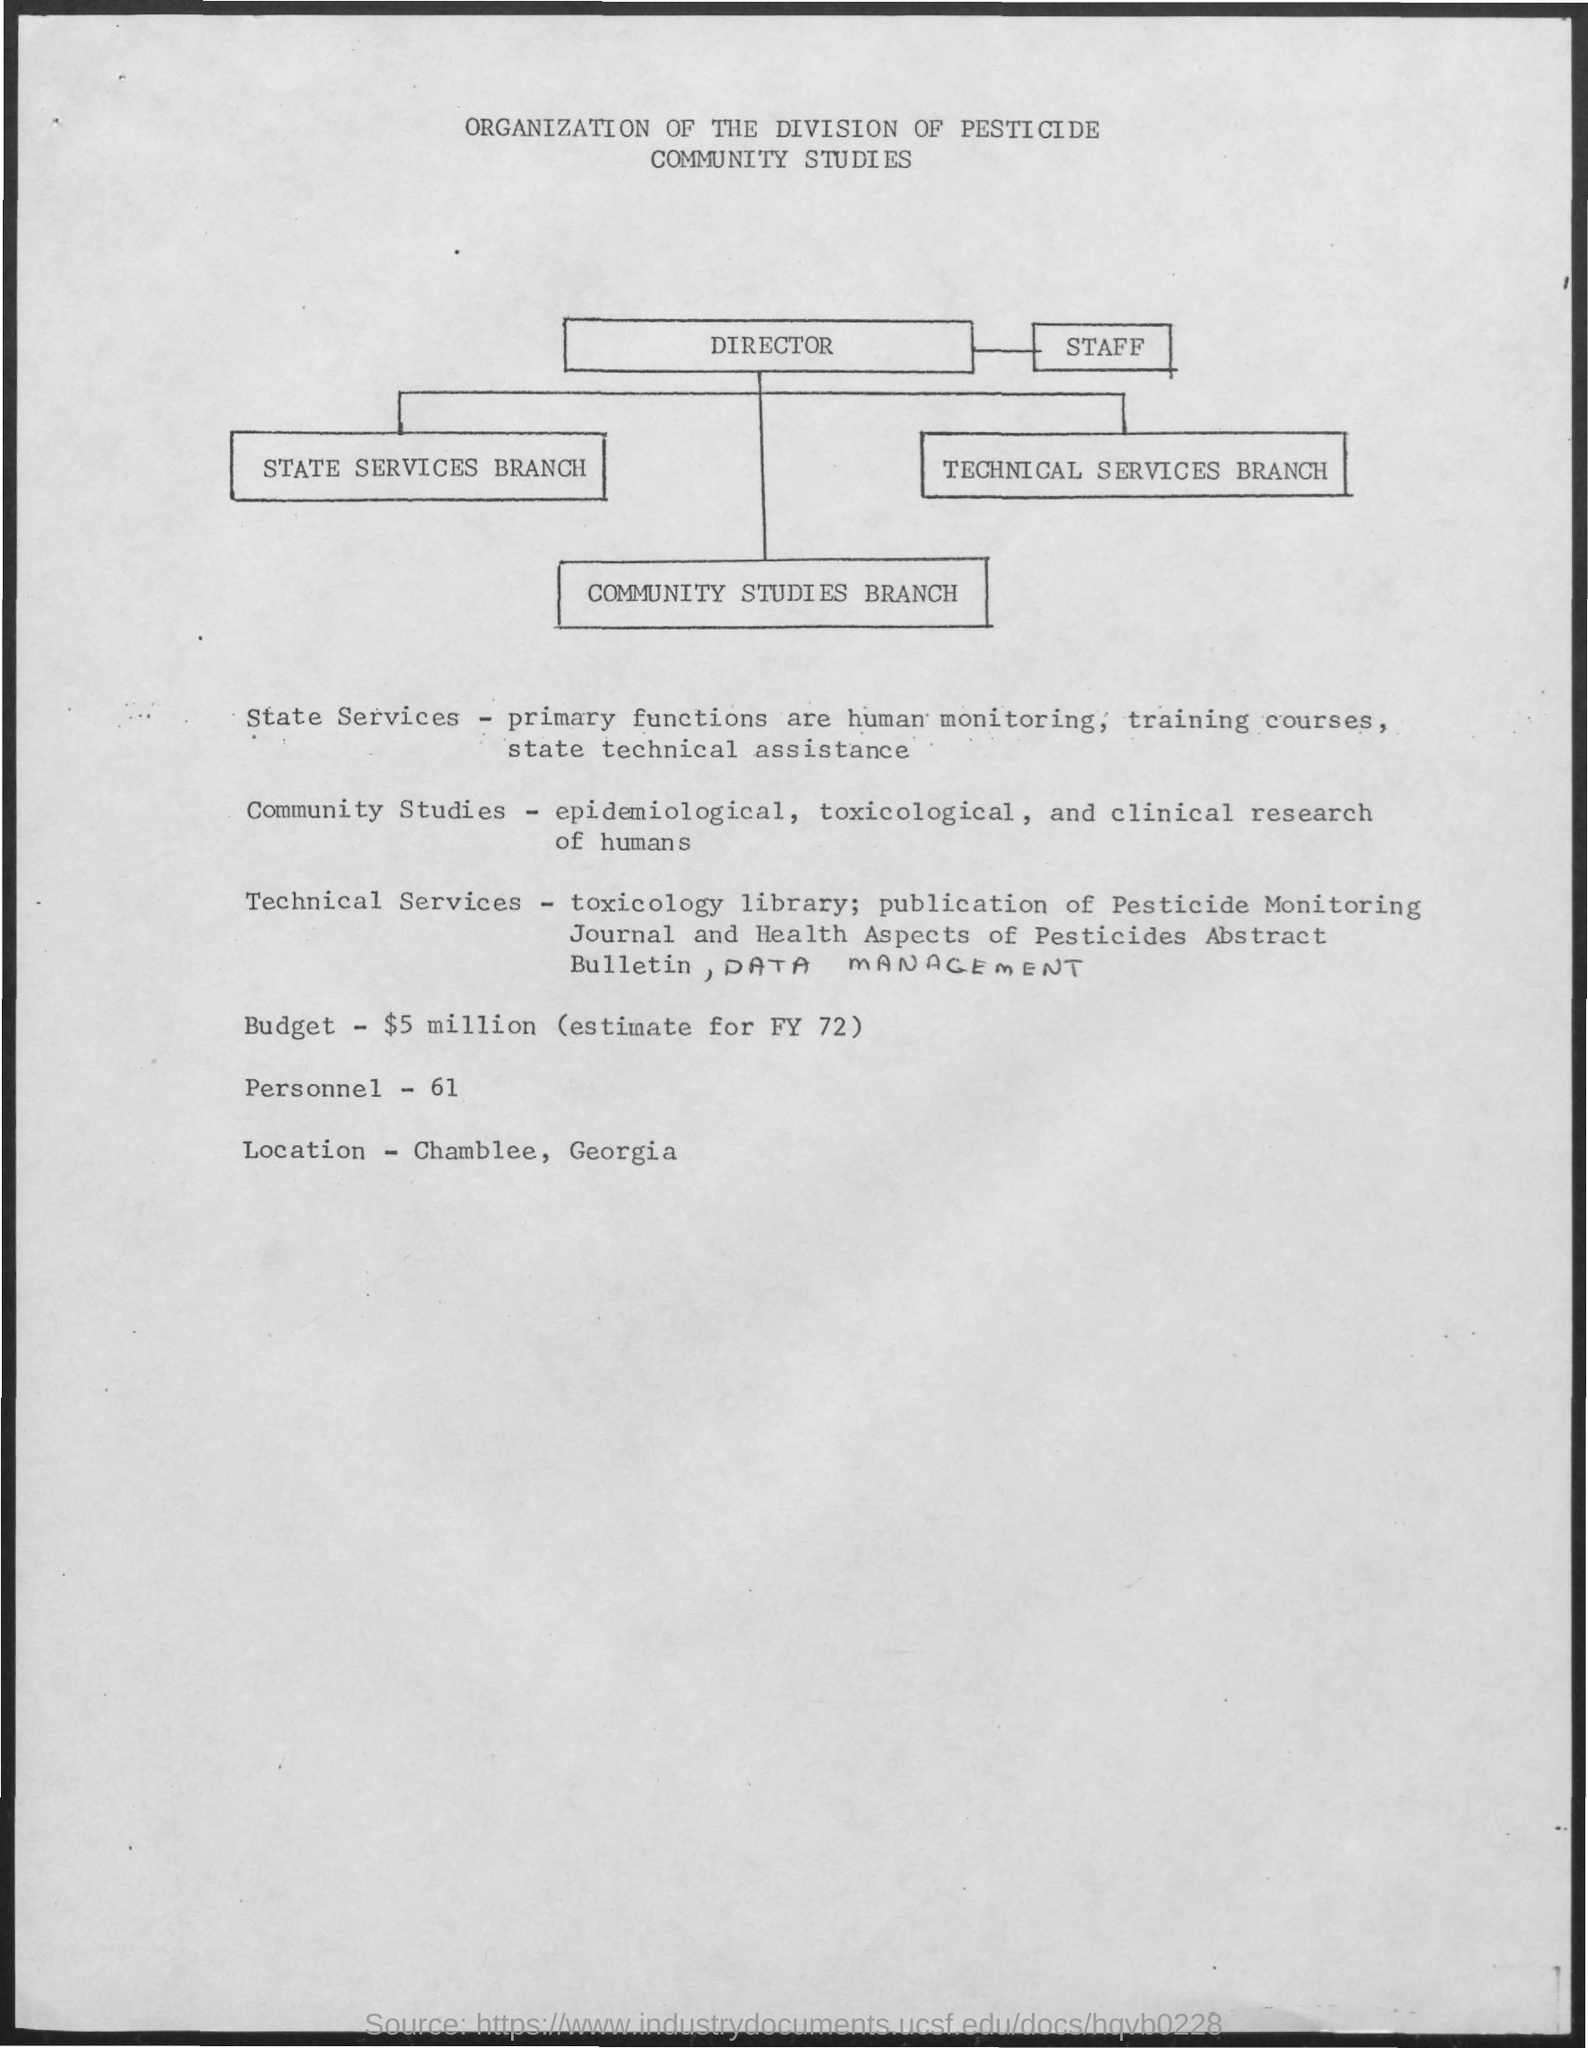Specify some key components in this picture. The budget is $5 million. The primary functions of [X entity/organization] are human monitoring, providing training courses, and offering technical assistance to the state. The location is Chamblee, Georgia. There are 61 personnel. 